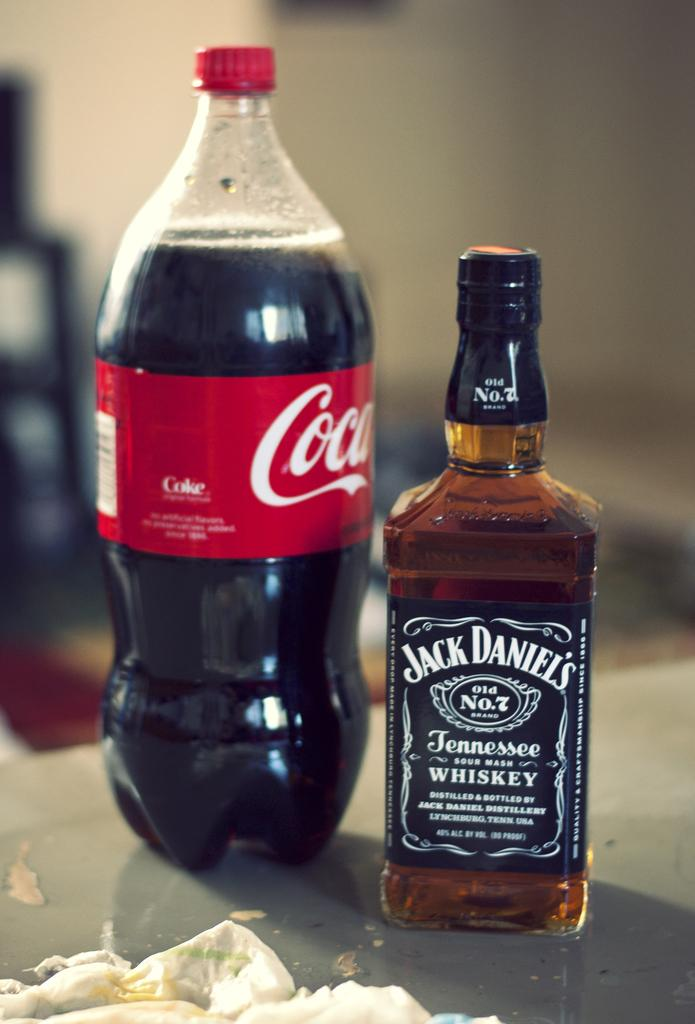What type of bottle is visible in the image? There is a Coca-Cola bottle with a red cap and a label in the image. Are there any other bottles in the image? Yes, there is another bottle with a label in the image. Where are the bottles located? Both bottles are on a table. What else can be seen on the table? There are items on the table. What direction does the Coca-Cola bottle face in the image? The direction the Coca-Cola bottle faces cannot be determined from the image. What does the Coca-Cola bottle smell like in the image? The image does not provide any information about the smell of the Coca-Cola bottle. 